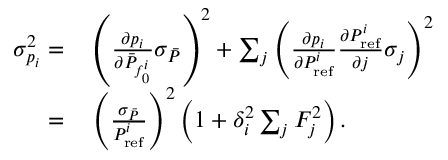Convert formula to latex. <formula><loc_0><loc_0><loc_500><loc_500>\begin{array} { r l } { \sigma _ { p _ { i } } ^ { 2 } = } & \left ( \frac { \partial p _ { i } } { \partial \bar { P } _ { f _ { 0 } ^ { i } } } \sigma _ { \bar { P } } \right ) ^ { 2 } + \sum _ { j } \left ( \frac { \partial p _ { i } } { \partial P _ { r e f } ^ { i } } \frac { \partial P _ { r e f } ^ { i } } { \partial j } \sigma _ { j } \right ) ^ { 2 } } \\ { = } & \left ( \frac { \sigma _ { \bar { P } } } { P _ { r e f } ^ { i } } \right ) ^ { 2 } \left ( 1 + \delta _ { i } ^ { 2 } \sum _ { j } F _ { j } ^ { 2 } \right ) . } \end{array}</formula> 